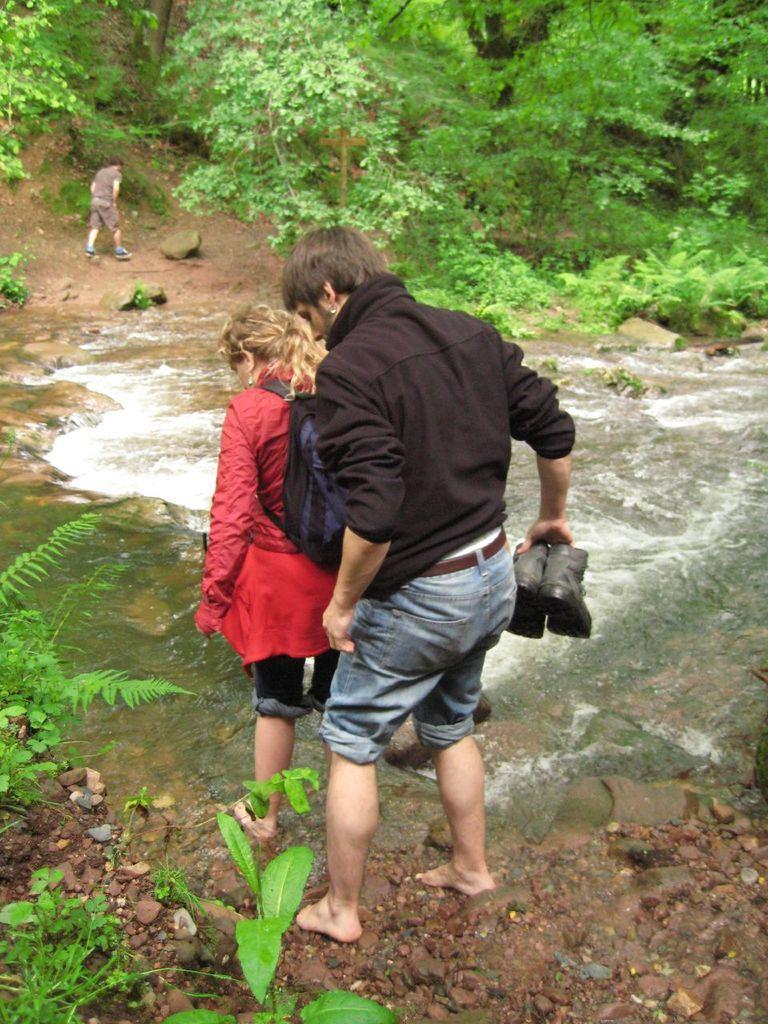How would you summarize this image in a sentence or two? This might be a picture taken in a forest or in a park. In this picture in the center there are two people crossing the water. In the foreground there is stones and mud. On the right there is water on the left there are plants. In the top right there is a man walking, and the background there are trees. 